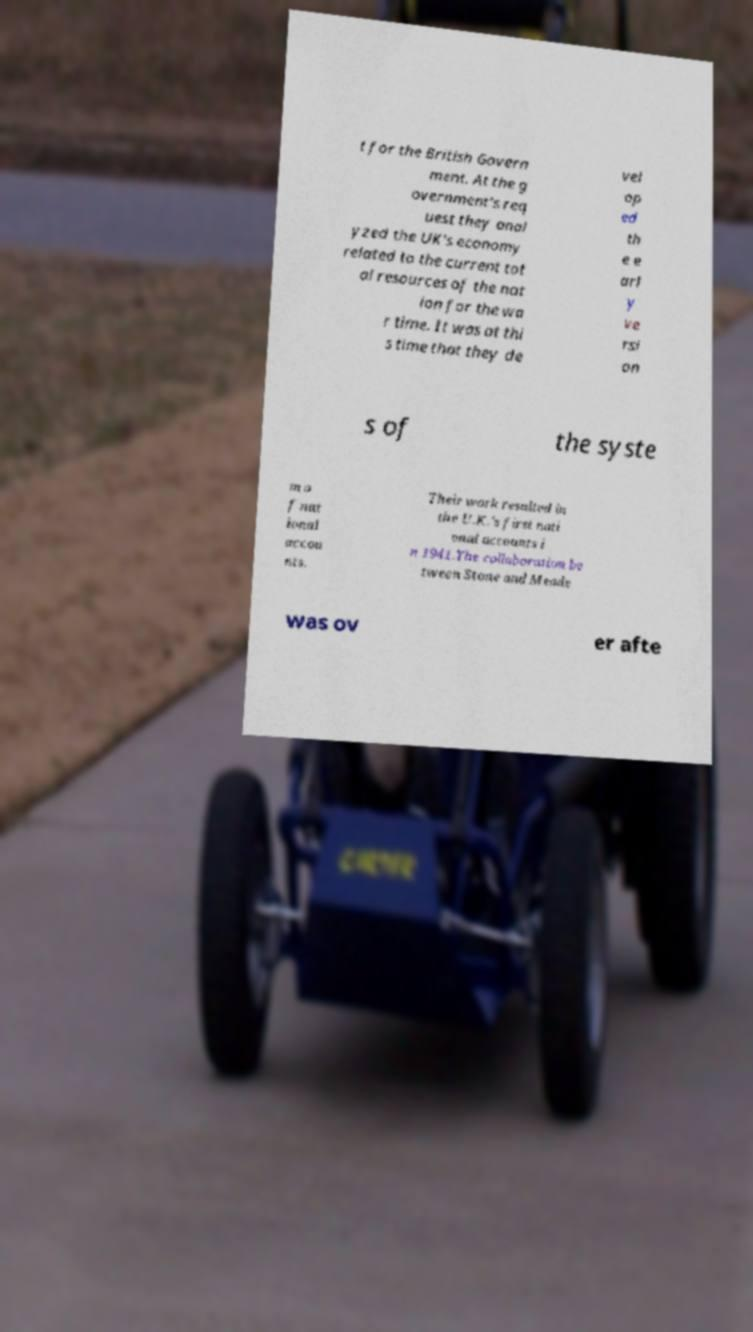Can you accurately transcribe the text from the provided image for me? t for the British Govern ment. At the g overnment's req uest they anal yzed the UK's economy related to the current tot al resources of the nat ion for the wa r time. It was at thi s time that they de vel op ed th e e arl y ve rsi on s of the syste m o f nat ional accou nts. Their work resulted in the U.K.'s first nati onal accounts i n 1941.The collaboration be tween Stone and Meade was ov er afte 